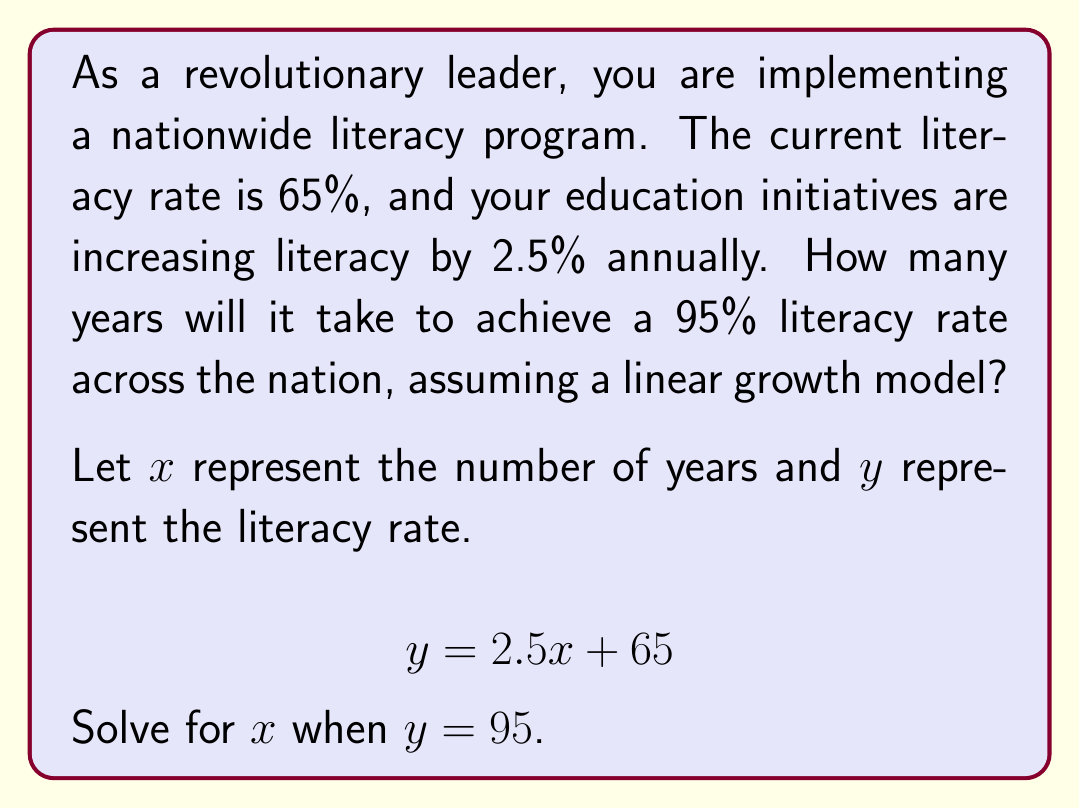Provide a solution to this math problem. To solve this problem, we'll follow these steps:

1) We start with the linear equation:
   $$y = 2.5x + 65$$

2) We want to find $x$ when $y = 95$, so we substitute this value:
   $$95 = 2.5x + 65$$

3) Subtract 65 from both sides:
   $$30 = 2.5x$$

4) Divide both sides by 2.5:
   $$\frac{30}{2.5} = x$$

5) Simplify:
   $$12 = x$$

Therefore, it will take 12 years to achieve a 95% literacy rate across the nation.

Note: This model assumes a constant rate of increase, which may not be realistic over a long period. In practice, the rate might slow down as it becomes harder to reach the last few percent of the population.
Answer: 12 years 